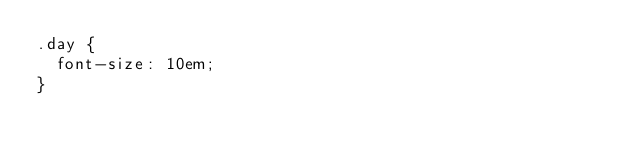Convert code to text. <code><loc_0><loc_0><loc_500><loc_500><_CSS_>.day {
  font-size: 10em;
}
</code> 